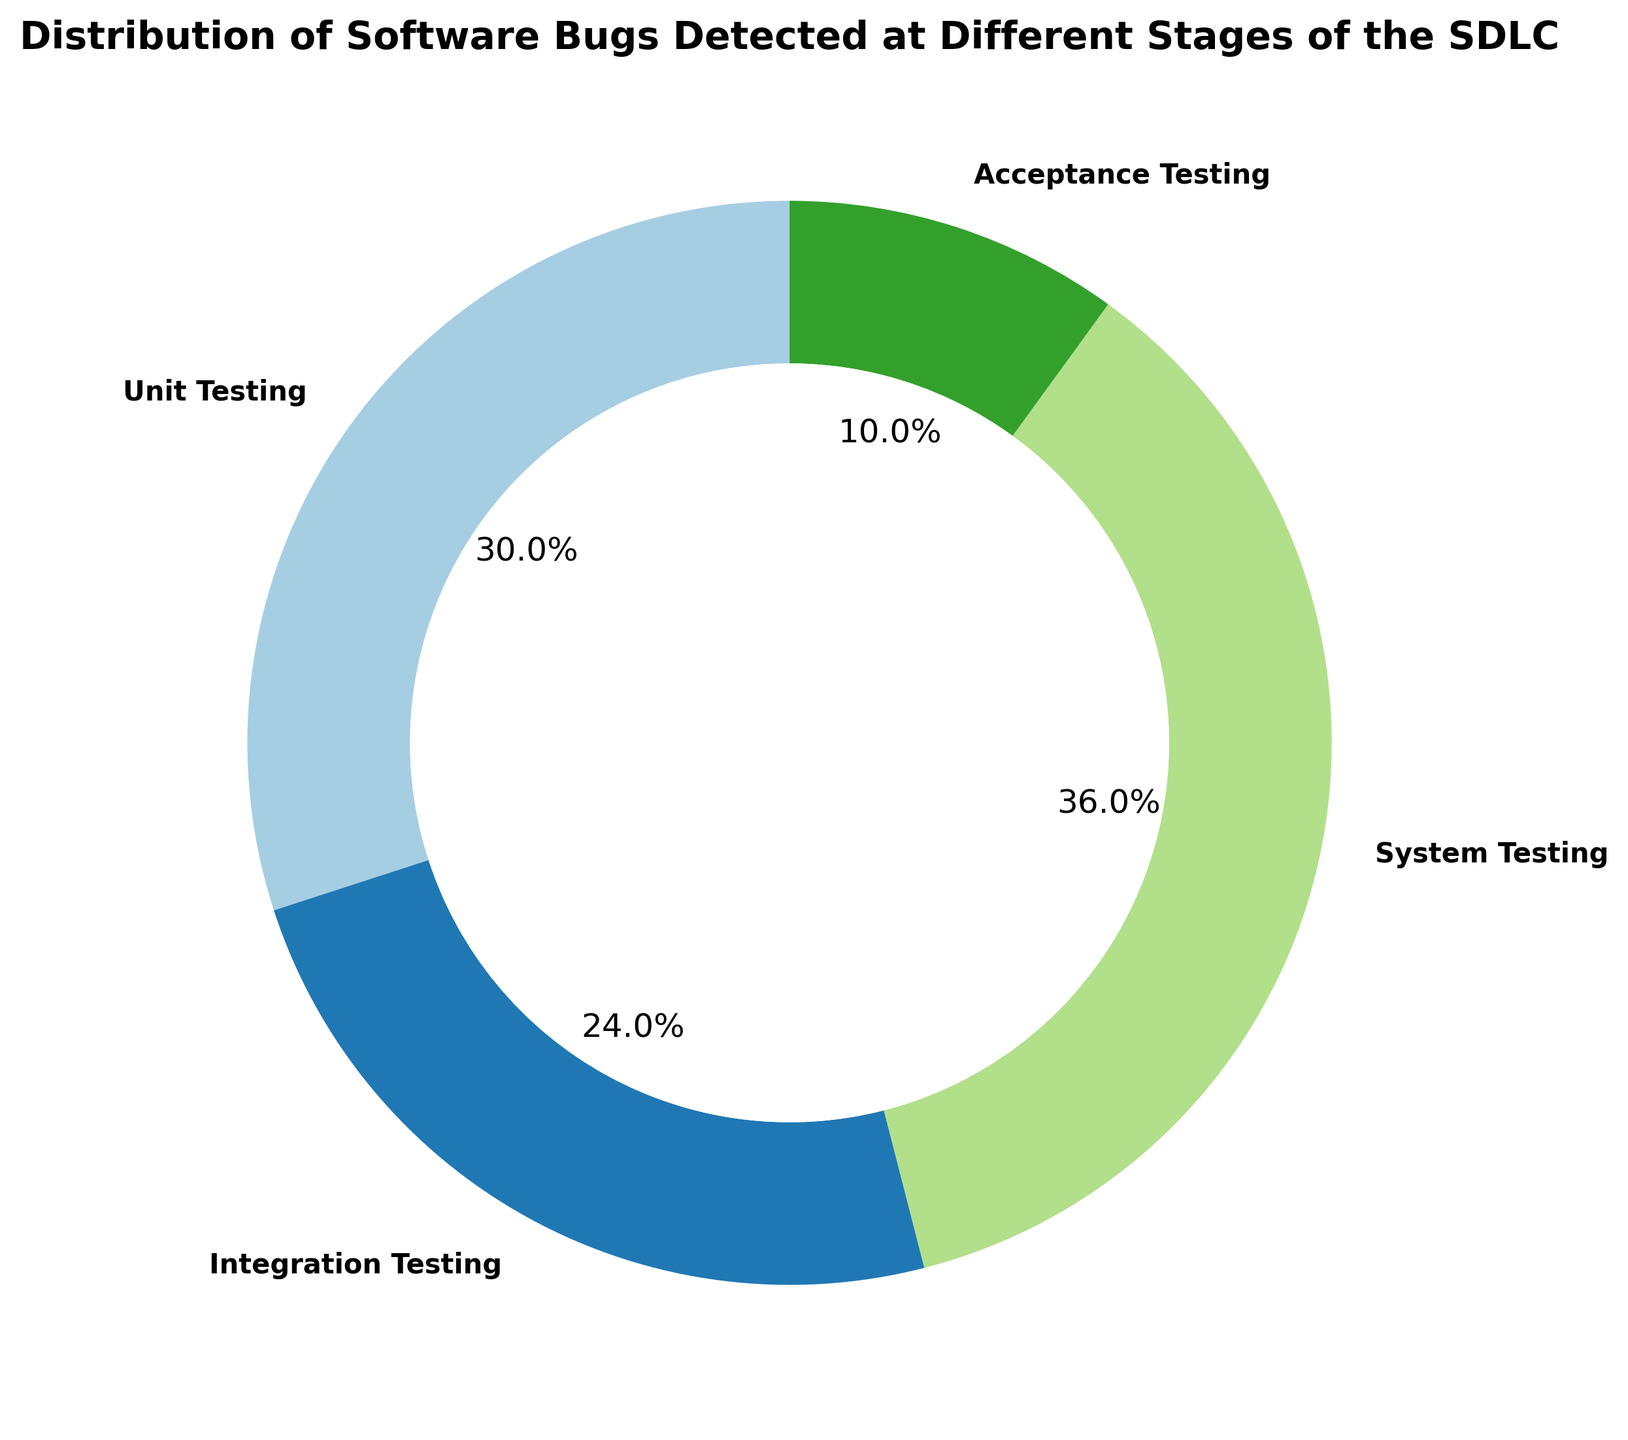What percentage of bugs were detected during unit testing? The ring chart indicates percentages within each testing phase. Locate the slice labeled "Unit Testing," which shows 150 bugs detected, and find the percentage marked there.
Answer: 33.3% Which phase detected fewer bugs: integration testing or acceptance testing? Inspect the ring chart slices labeled "Integration Testing" and "Acceptance Testing." Integration Testing detected 120 bugs, and Acceptance Testing detected 50 bugs.
Answer: Acceptance Testing How many more bugs were detected during system testing than acceptance testing? Identify the bug counts for System Testing (180) and Acceptance Testing (50). Calculate the difference: 180 - 50.
Answer: 130 What is the combined percentage of bugs detected during integration and system testing? Find the percentages for Integration Testing (120 bugs) and System Testing (180 bugs) in the ring chart. Sum the two percentages.
Answer: 50% Arrange the testing phases in ascending order based on the number of bugs detected. Read the bug counts for each phase from the chart: Acceptance Testing (50), Integration Testing (120), Unit Testing (150), and System Testing (180). Order these counts.
Answer: Acceptance Testing, Integration Testing, Unit Testing, System Testing Which phase detected the highest number of bugs, and what percentage of all bugs was that? Observe the slices in the ring chart and identify the phase with the highest bug count, which is System Testing (180 bugs). Check the slice's percentage.
Answer: System Testing, 40.0% What is the visual color representation for unit testing? Look at the slice labeled "Unit Testing" and note its color.
Answer: Blue What fraction of the total bugs were detected during unit and integration testing combined? Identify the bug counts for Unit Testing (150) and Integration Testing (120). Sum the counts to get 150 + 120 = 270, and divide by the total number of bugs (150 + 120 + 180 + 50 = 500). Simplify the fraction 270/500.
Answer: 27/50 How does the proportion of bugs detected during acceptance testing compare visually to system testing? Notice the relative size of the two slices labeled "Acceptance Testing" and "System Testing." Acceptance Testing appears much smaller in comparison.
Answer: Acceptance Testing's slice is significantly smaller Calculate the average number of bugs detected across all phases. Sum the bug counts for all phases (150 + 120 + 180 + 50 = 500), and divide by the number of phases (4).
Answer: 125 